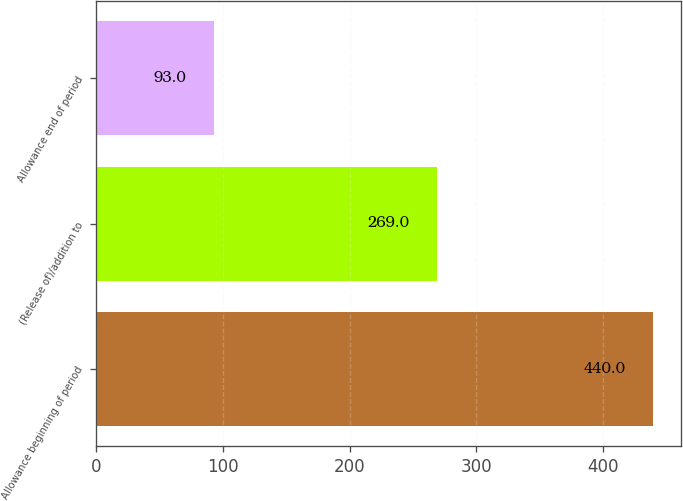Convert chart. <chart><loc_0><loc_0><loc_500><loc_500><bar_chart><fcel>Allowance beginning of period<fcel>(Release of)/addition to<fcel>Allowance end of period<nl><fcel>440<fcel>269<fcel>93<nl></chart> 